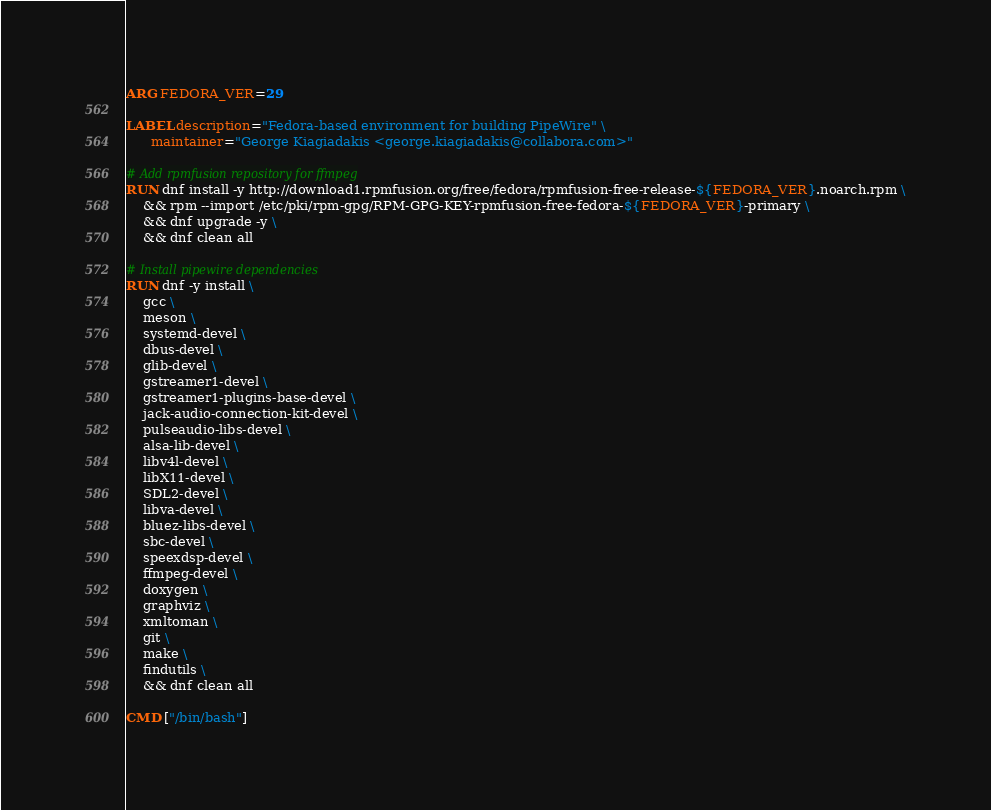<code> <loc_0><loc_0><loc_500><loc_500><_Dockerfile_>ARG FEDORA_VER=29

LABEL description="Fedora-based environment for building PipeWire" \
      maintainer="George Kiagiadakis <george.kiagiadakis@collabora.com>"

# Add rpmfusion repository for ffmpeg
RUN dnf install -y http://download1.rpmfusion.org/free/fedora/rpmfusion-free-release-${FEDORA_VER}.noarch.rpm \
    && rpm --import /etc/pki/rpm-gpg/RPM-GPG-KEY-rpmfusion-free-fedora-${FEDORA_VER}-primary \
    && dnf upgrade -y \
    && dnf clean all

# Install pipewire dependencies
RUN dnf -y install \
    gcc \
    meson \
    systemd-devel \
    dbus-devel \
    glib-devel \
    gstreamer1-devel \
    gstreamer1-plugins-base-devel \
    jack-audio-connection-kit-devel \
    pulseaudio-libs-devel \
    alsa-lib-devel \
    libv4l-devel \
    libX11-devel \
    SDL2-devel \
    libva-devel \
    bluez-libs-devel \
    sbc-devel \
    speexdsp-devel \
    ffmpeg-devel \
    doxygen \
    graphviz \
    xmltoman \
    git \
    make \
    findutils \
    && dnf clean all

CMD ["/bin/bash"]
</code> 